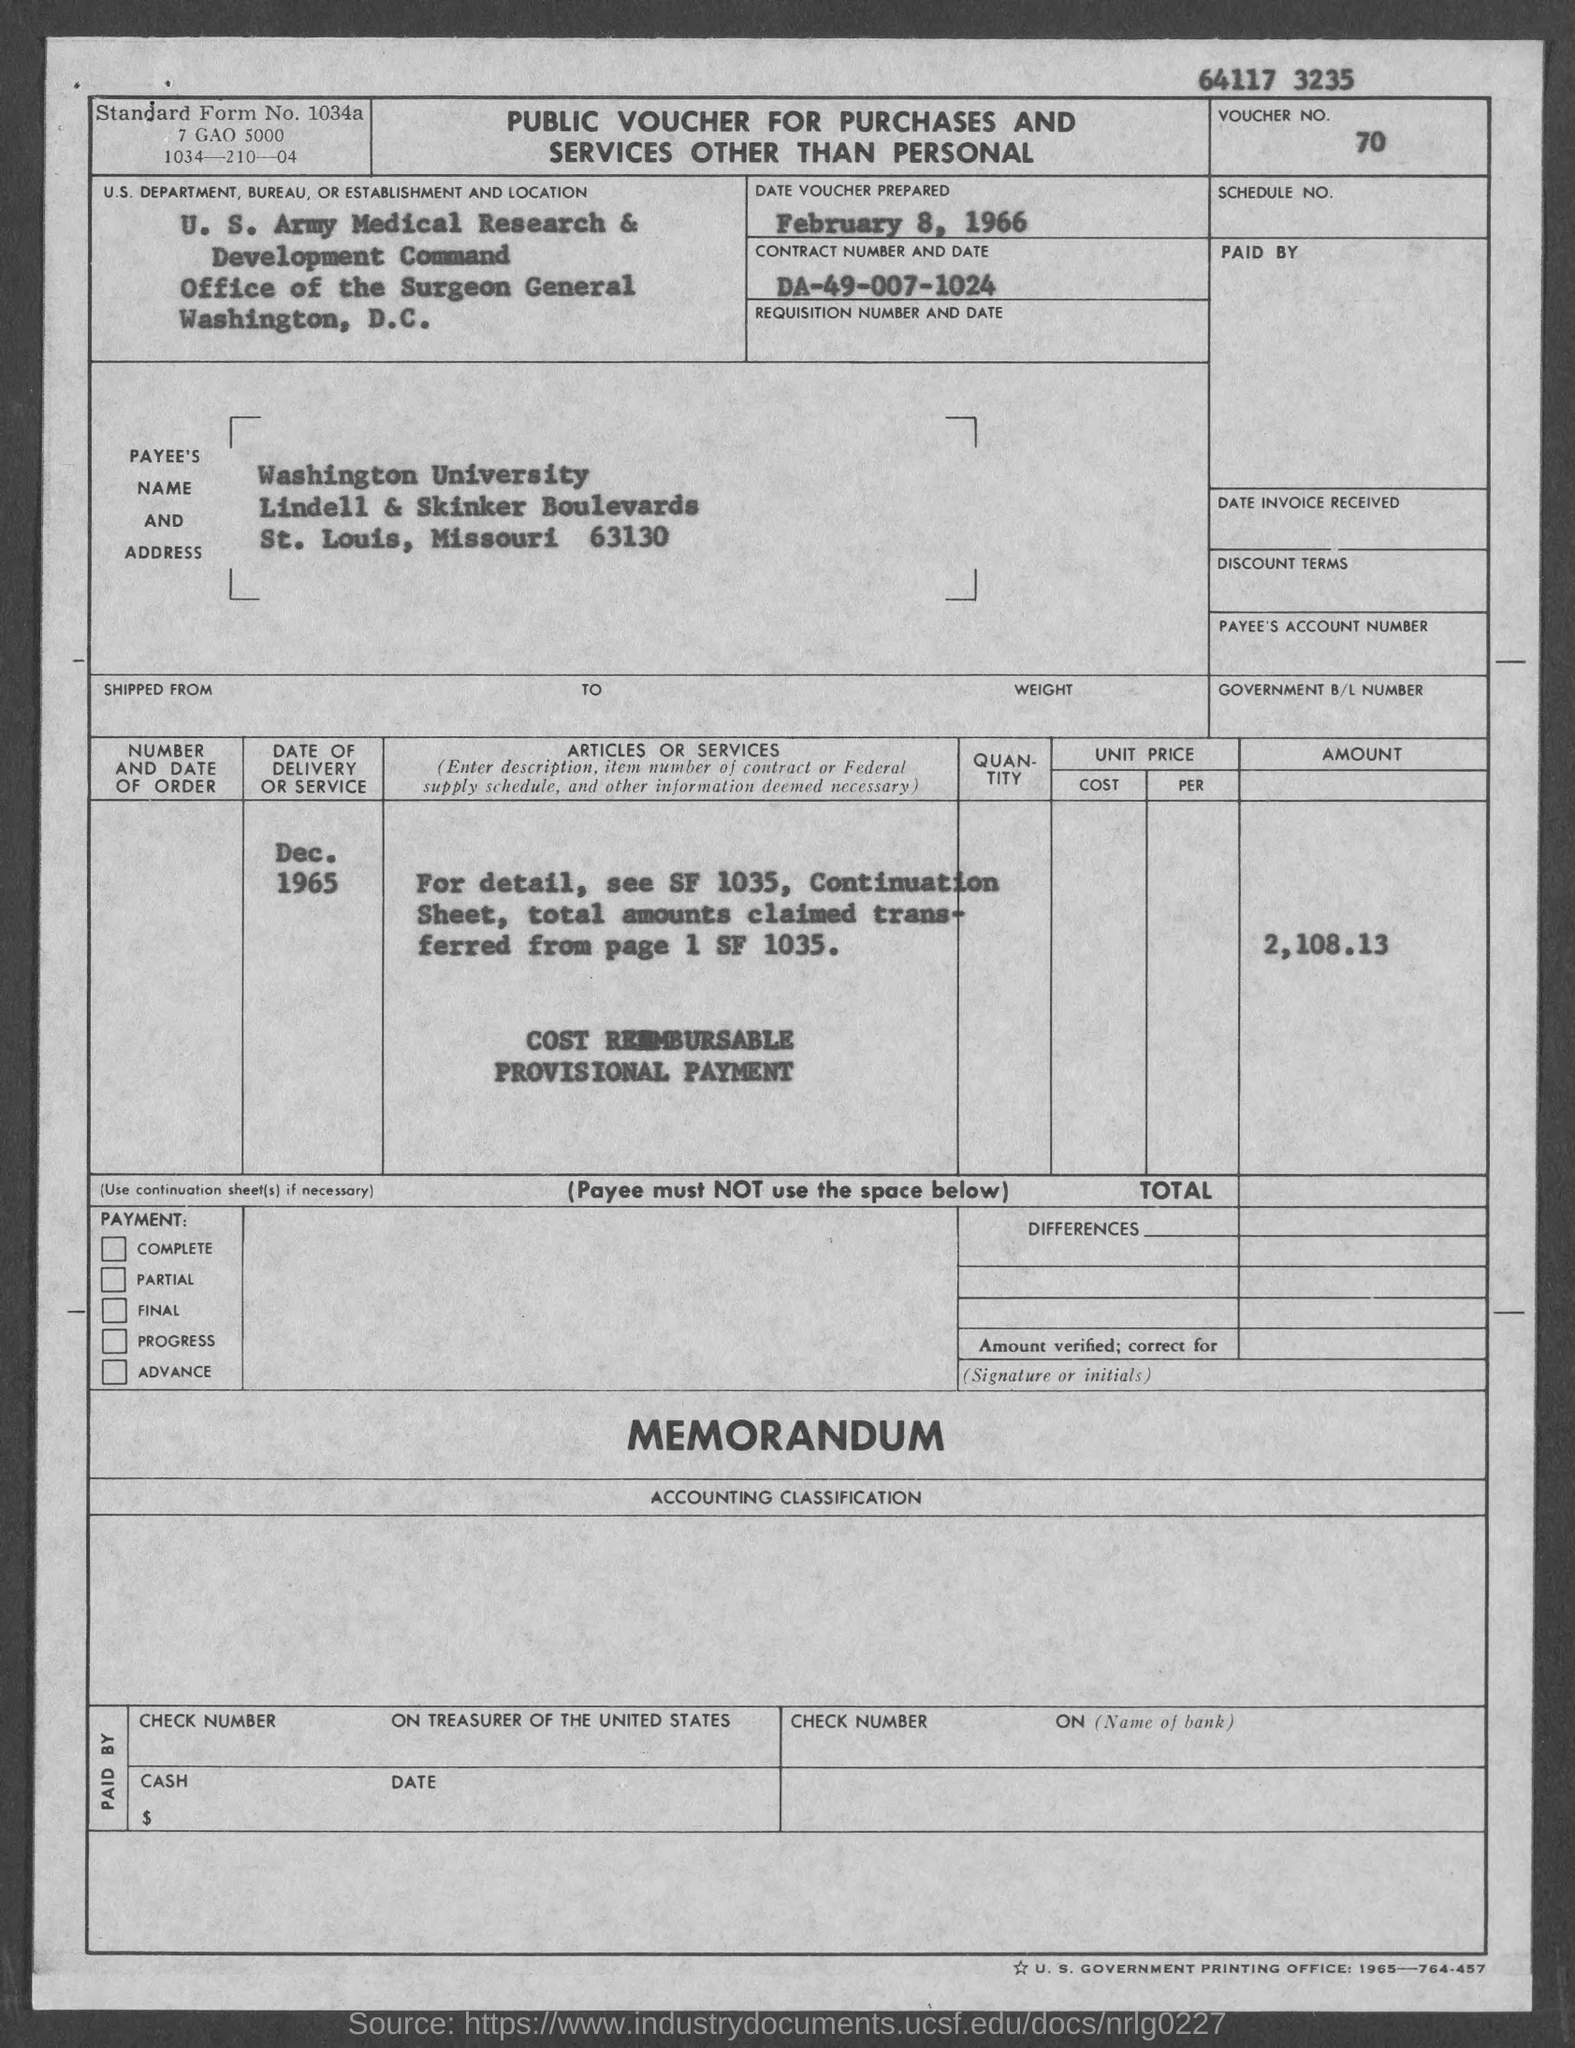What is the voucher no.?
Provide a succinct answer. 70. What is the contract number ?
Provide a short and direct response. DA-49-007-1024. In which city is office of the surgeon general at?
Provide a short and direct response. Washington. In which state is washington university located ?
Make the answer very short. Missouri. What is the standard form no.?
Provide a short and direct response. 1034a. 